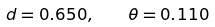<formula> <loc_0><loc_0><loc_500><loc_500>d = 0 . 6 5 0 , \quad \theta = 0 . 1 1 0</formula> 